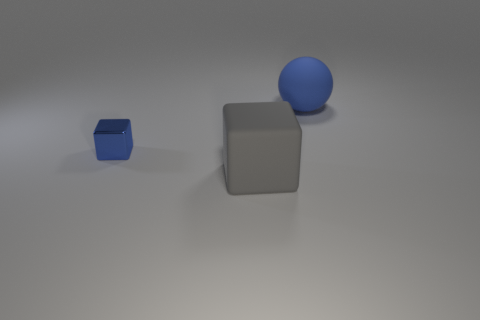Are there any brown matte things that have the same size as the gray matte object?
Keep it short and to the point. No. There is a large rubber object that is in front of the small metal object; is its shape the same as the large blue object?
Keep it short and to the point. No. What is the large thing behind the big gray matte thing made of?
Offer a very short reply. Rubber. There is a big object that is on the right side of the big rubber object in front of the blue shiny cube; what is its shape?
Your answer should be compact. Sphere. Is the shape of the gray rubber object the same as the blue thing that is to the left of the big rubber ball?
Make the answer very short. Yes. There is a block behind the large rubber cube; how many big blue rubber balls are on the left side of it?
Your answer should be very brief. 0. There is a big gray object that is the same shape as the blue shiny object; what is its material?
Provide a short and direct response. Rubber. How many gray objects are either metallic cubes or cubes?
Your response must be concise. 1. Is there any other thing of the same color as the large matte block?
Keep it short and to the point. No. What color is the large object behind the large object in front of the small thing?
Your answer should be compact. Blue. 